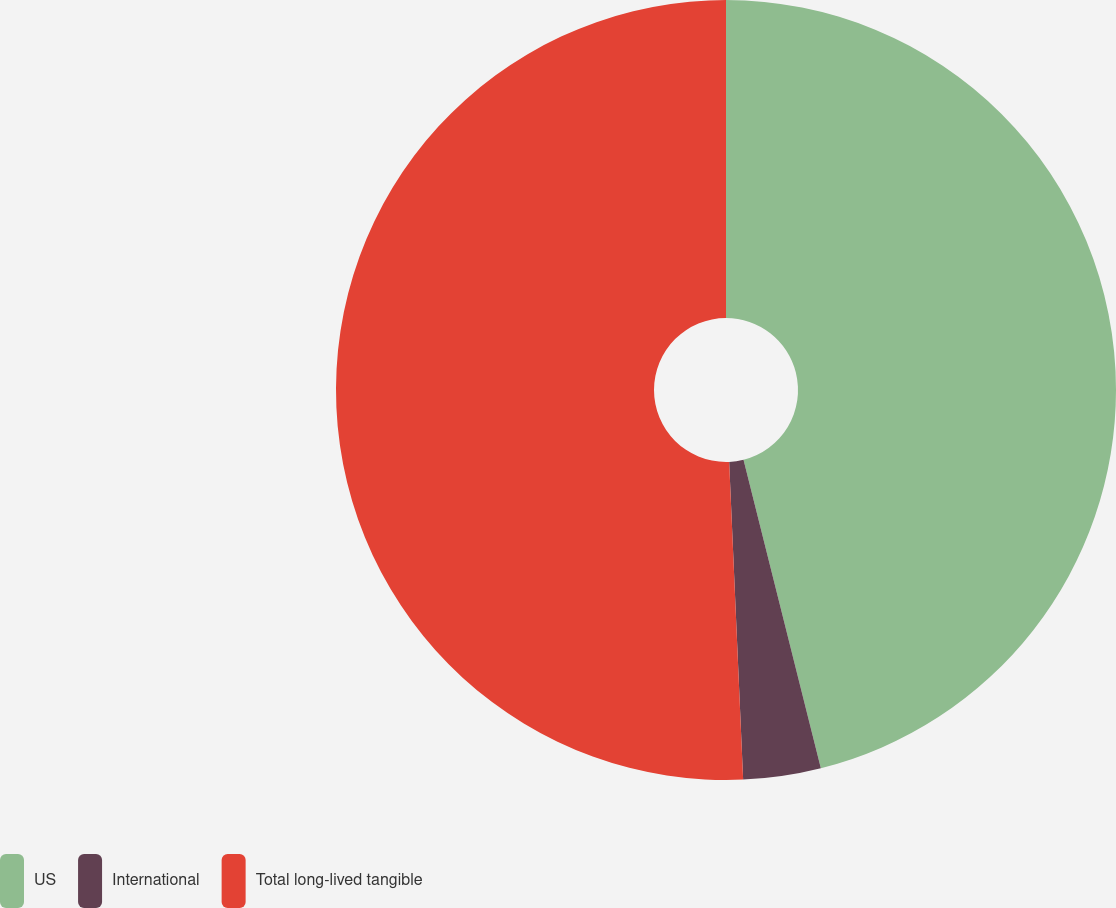Convert chart. <chart><loc_0><loc_0><loc_500><loc_500><pie_chart><fcel>US<fcel>International<fcel>Total long-lived tangible<nl><fcel>46.09%<fcel>3.21%<fcel>50.7%<nl></chart> 